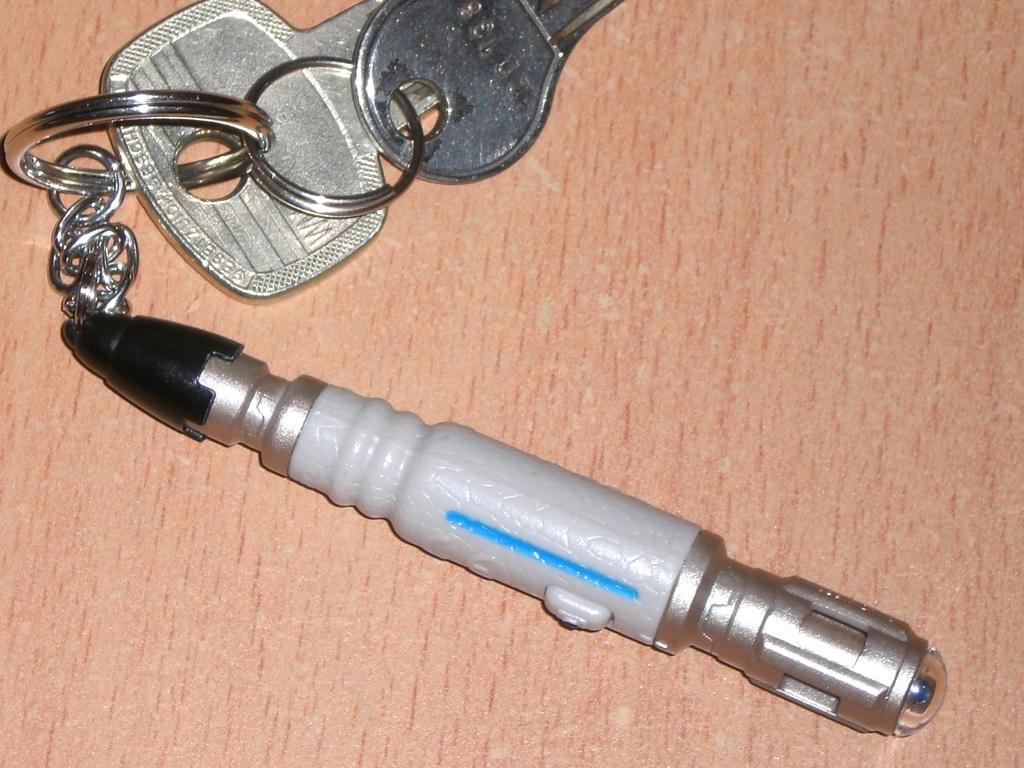How would you summarize this image in a sentence or two? In this image I can see keys with a keychain. It is looking like a laser light. 